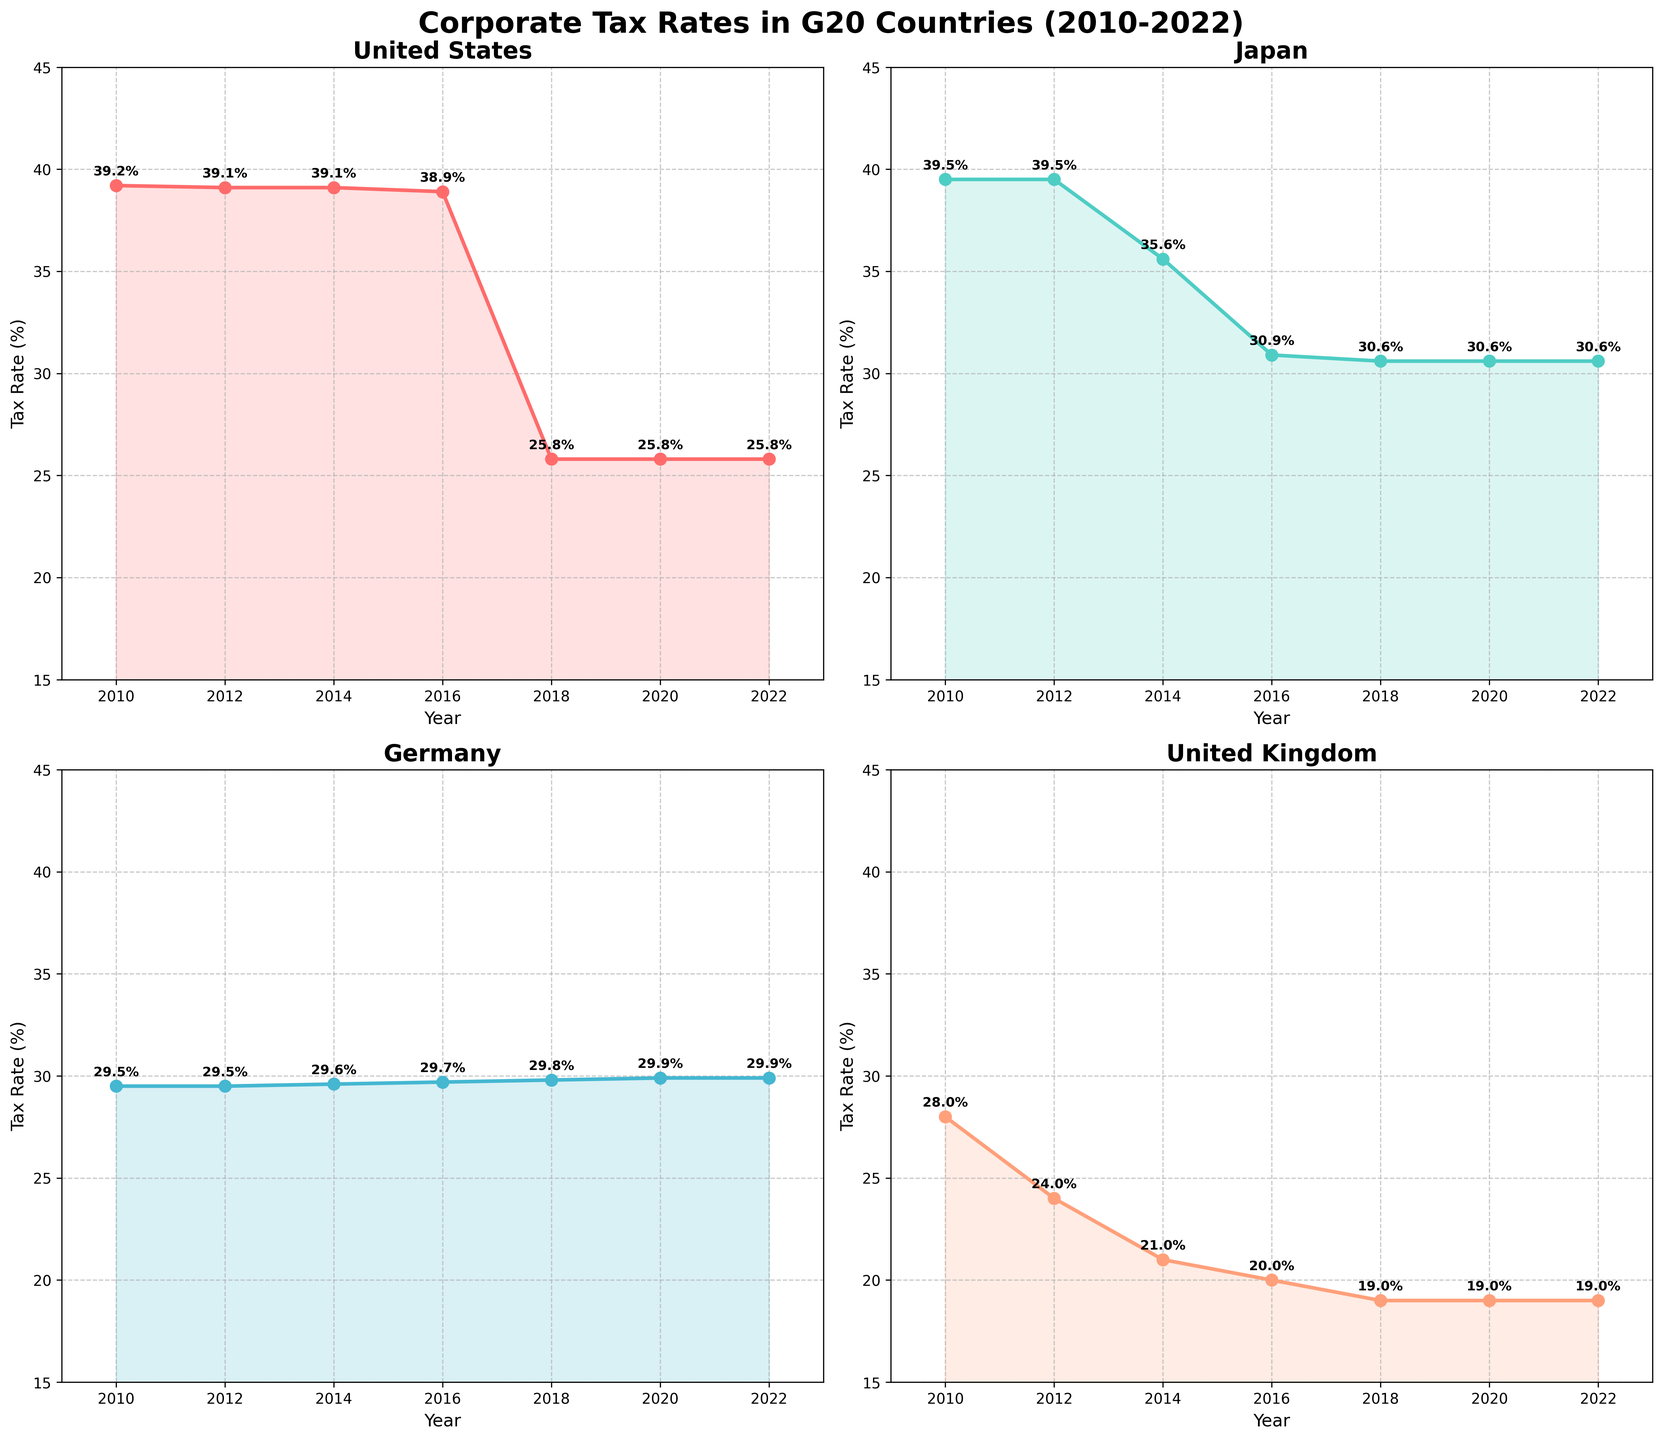What is the title of the figure? The title of the figure is located at the top of the image and describes the overall content being represented. The title in this case states the main topic or subject that the plots address.
Answer: Corporate Tax Rates in G20 Countries (2010-2022) Which country had the highest corporate tax rate in 2010? Look at the subplot for each country and compare the starting point on the y-axis in the year 2010. Identify the country with the highest value.
Answer: Japan What is the trend of corporate tax rates in the United States from 2010 to 2022? Examine the plot for the United States. Observe the slope of the line, noting whether it increases, decreases, or remains constant over the years 2010 to 2022.
Answer: Decreasing How does the corporate tax rate in Japan in 2022 compare to its rate in 2010? Find the points for Japan in 2010 and 2022. Compare the values by noting the positions on the y-axis for these two years.
Answer: Decreased from 39.5% to 30.6% Between which years did the United Kingdom experience the largest drop in corporate tax rates? Focus on the subplot for the United Kingdom and observe the points where the rate decreased most sharply. Identify the pair of years with the largest vertical drop between them.
Answer: 2010 to 2012 What is the common lowest corporate tax rate reached by any country in the subplots from 2010 to 2022? Locate the minimum points of the tax rates in all subplots. Identify the lowest value among these points.
Answer: 19.0% Which country showed the least variation in corporate tax rates over the given period? Determine which subplot has the smallest range between its maximum and minimum values over the period.
Answer: Germany What is the difference in the corporate tax rate of France between 2016 and 2022? Find the points for France in the years 2016 and 2022. Subtract the 2022 value from the 2016 value to find the difference.
Answer: 8.6% Which country had a consistent corporate tax rate between 2016 and 2022? Look across the subplots for lines where the rate remains consistent (unchanged) from 2016 to 2022.
Answer: China How did the corporate tax rates in Canada change over the years 2010 to 2022? This question falls under compositional analysis. Observe the points in the subplot for Canada and note changes year over year.
Answer: Decreased slightly from 2010 to 2012, then mostly remained stable around 26.5% to 26.8% 